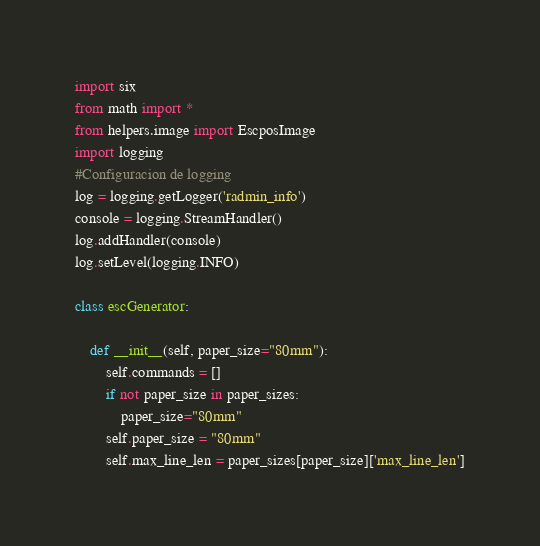Convert code to text. <code><loc_0><loc_0><loc_500><loc_500><_Python_>import six
from math import *
from helpers.image import EscposImage
import logging
#Configuracion de logging
log = logging.getLogger('radmin_info')
console = logging.StreamHandler()
log.addHandler(console)
log.setLevel(logging.INFO)

class escGenerator:

    def __init__(self, paper_size="80mm"):
        self.commands = []
        if not paper_size in paper_sizes:
            paper_size="80mm"
        self.paper_size = "80mm"
        self.max_line_len = paper_sizes[paper_size]['max_line_len']</code> 